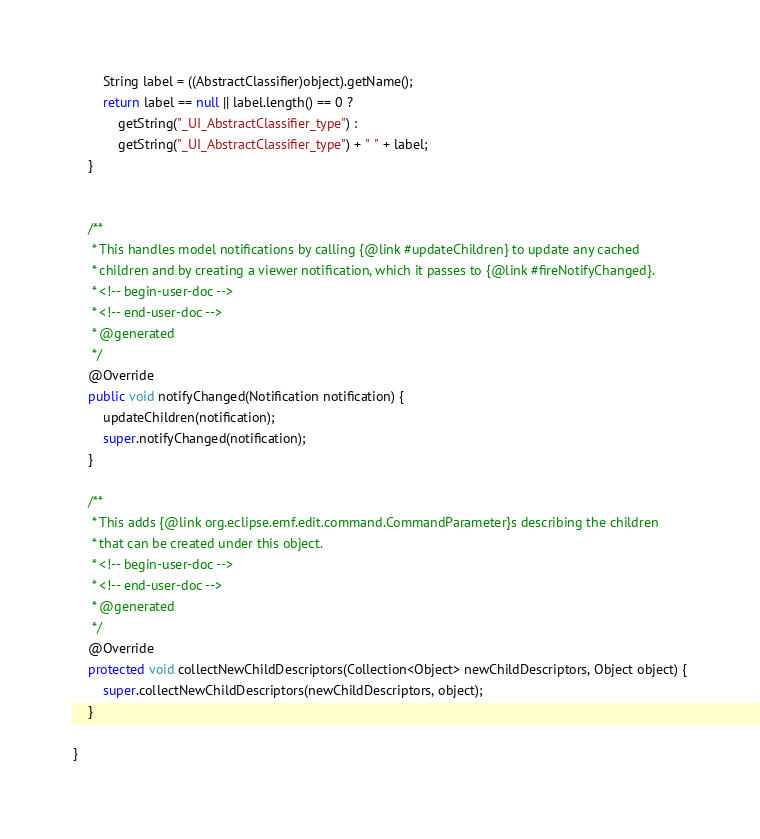Convert code to text. <code><loc_0><loc_0><loc_500><loc_500><_Java_>		String label = ((AbstractClassifier)object).getName();
		return label == null || label.length() == 0 ?
			getString("_UI_AbstractClassifier_type") :
			getString("_UI_AbstractClassifier_type") + " " + label;
	}
	

	/**
	 * This handles model notifications by calling {@link #updateChildren} to update any cached
	 * children and by creating a viewer notification, which it passes to {@link #fireNotifyChanged}.
	 * <!-- begin-user-doc -->
	 * <!-- end-user-doc -->
	 * @generated
	 */
	@Override
	public void notifyChanged(Notification notification) {
		updateChildren(notification);
		super.notifyChanged(notification);
	}

	/**
	 * This adds {@link org.eclipse.emf.edit.command.CommandParameter}s describing the children
	 * that can be created under this object.
	 * <!-- begin-user-doc -->
	 * <!-- end-user-doc -->
	 * @generated
	 */
	@Override
	protected void collectNewChildDescriptors(Collection<Object> newChildDescriptors, Object object) {
		super.collectNewChildDescriptors(newChildDescriptors, object);
	}

}
</code> 